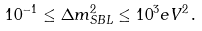Convert formula to latex. <formula><loc_0><loc_0><loc_500><loc_500>1 0 ^ { - 1 } \leq \Delta m ^ { 2 } _ { S B L } \leq 1 0 ^ { 3 } e V ^ { 2 } \, .</formula> 